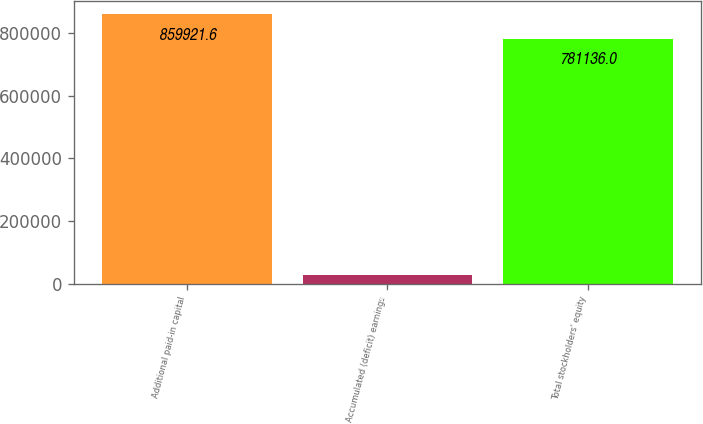Convert chart to OTSL. <chart><loc_0><loc_0><loc_500><loc_500><bar_chart><fcel>Additional paid-in capital<fcel>Accumulated (deficit) earnings<fcel>Total stockholders' equity<nl><fcel>859922<fcel>29602<fcel>781136<nl></chart> 